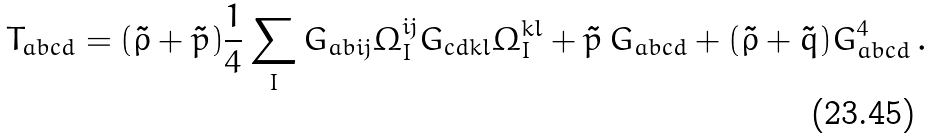<formula> <loc_0><loc_0><loc_500><loc_500>T _ { a b c d } = ( \tilde { \rho } + \tilde { p } ) \frac { 1 } { 4 } \sum _ { I } G _ { a b i j } \Omega ^ { i j } _ { I } G _ { c d k l } \Omega ^ { k l } _ { I } + \tilde { p } \, G _ { a b c d } + ( \tilde { \rho } + \tilde { q } ) G ^ { 4 } _ { a b c d } \, .</formula> 